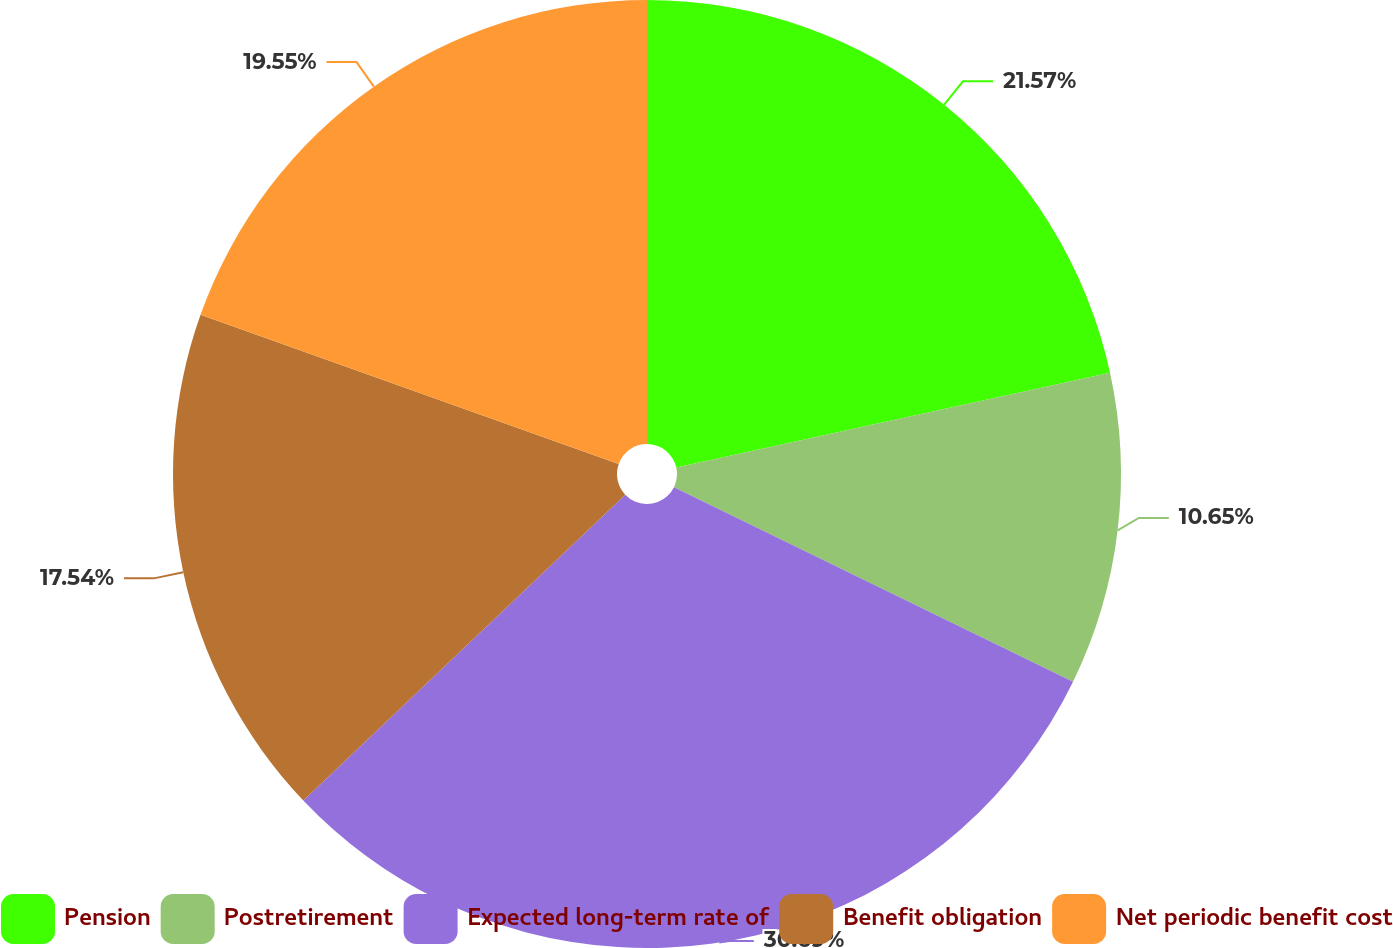Convert chart. <chart><loc_0><loc_0><loc_500><loc_500><pie_chart><fcel>Pension<fcel>Postretirement<fcel>Expected long-term rate of<fcel>Benefit obligation<fcel>Net periodic benefit cost<nl><fcel>21.57%<fcel>10.65%<fcel>30.69%<fcel>17.54%<fcel>19.55%<nl></chart> 